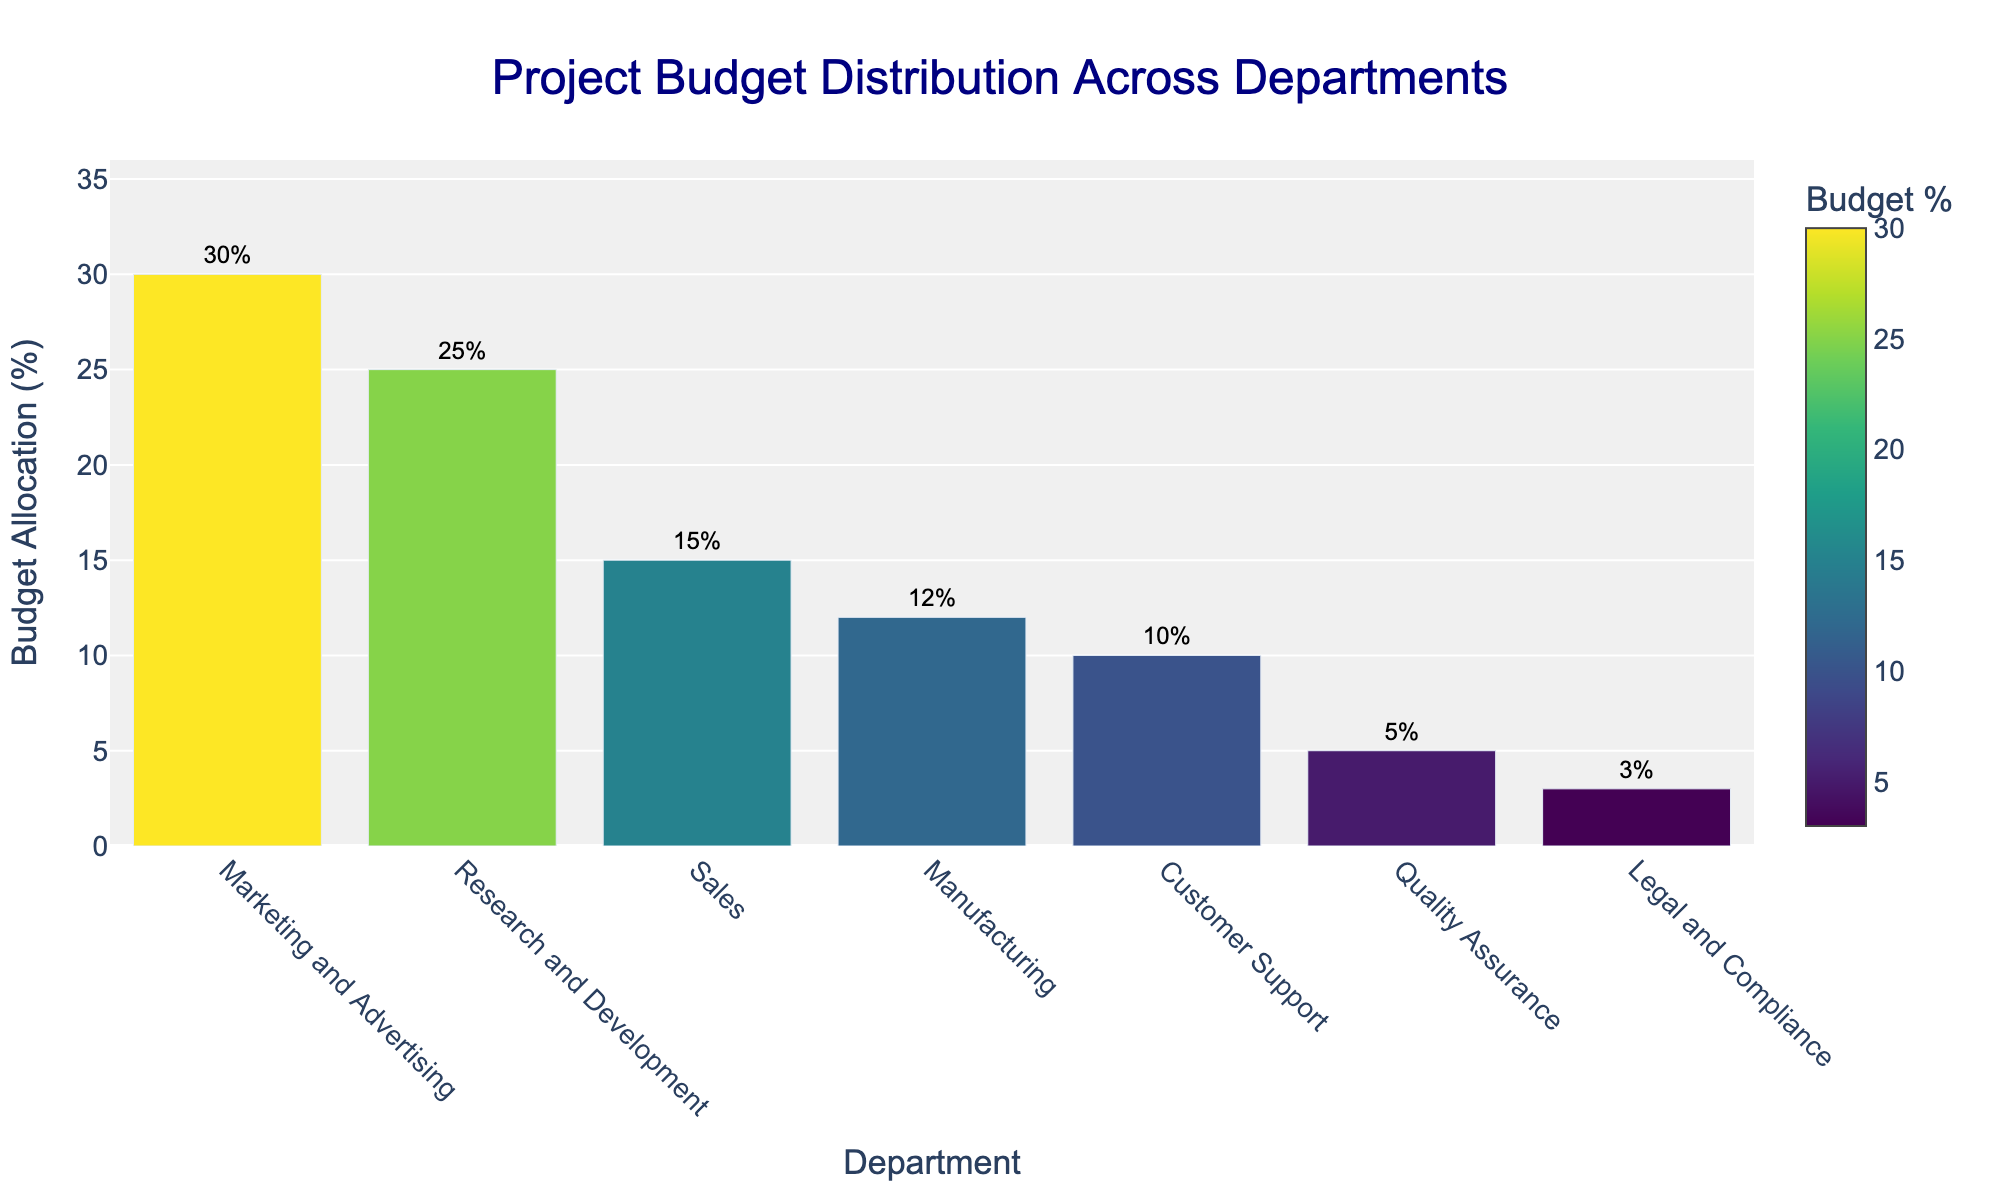Which department has the highest budget allocation? By looking at the bar heights in the chart, the department with the tallest bar has the highest budget allocation. Examine the bars and identify that "Marketing and Advertising" has the highest allocation.
Answer: Marketing and Advertising How much more budget does Marketing and Advertising have compared to Customer Support? Find the budget allocation percentages for Marketing and Advertising (30%) and Customer Support (10%). Subtract the smaller from the larger: 30% - 10% = 20%.
Answer: 20% What is the total budget allocation for departments with less than 10% allocation each? Identify the departments with less than 10% allocation: Quality Assurance (5%) and Legal and Compliance (3%). Sum these values: 5% + 3% = 8%.
Answer: 8% Which department has the lowest budget allocation, and what is it? Find the department with the shortest bar in the chart, which is Legal and Compliance. The value for this department is 3%.
Answer: Legal and Compliance, 3% What is the combined budget allocation for Research and Development and Manufacturing? Find the budget allocation percentages for Research and Development (25%) and Manufacturing (12%). Sum these values: 25% + 12% = 37%.
Answer: 37% Are there any departments with equal budget allocations? Examine the bar heights and values to see if any two departments have the same budget allocation. All departments have different allocation percentages.
Answer: No Which department has the third-highest budget allocation, and how much is it? List the departments in descending order of their budget allocations: Marketing and Advertising (30%), Research and Development (25%), and Sales (15%). The third-highest is Sales with 15%.
Answer: Sales, 15% What is the difference in budget allocation between the department with the highest budget and the one with the lowest budget? Identify the highest budget allocation (Marketing and Advertising, 30%) and the lowest (Legal and Compliance, 3%). Subtract the smaller from the larger: 30% - 3% = 27%.
Answer: 27% By how much does the budget allocation for Sales exceed that of Quality Assurance? Find the budget percentages for Sales (15%) and Quality Assurance (5%). Subtract the smaller from the larger: 15% - 5% = 10%.
Answer: 10% What percentage of the total budget is allocated to departments other than Marketing and Advertising? The total allocation for all departments is 100%. Subtract the allocation for Marketing and Advertising (30%): 100% - 30% = 70%.
Answer: 70% 